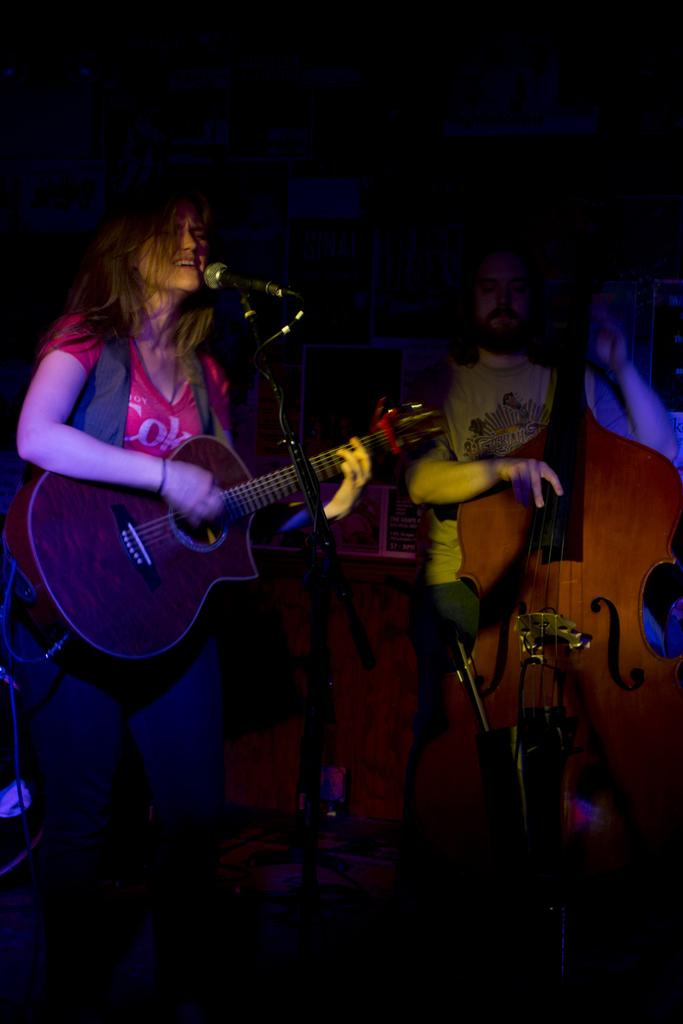What is the main subject of the image? The main subject of the image is a woman. What is the woman doing in the image? The woman is standing, singing, and holding a guitar. What object is the woman using to amplify her voice? There is a microphone ine in the image that the woman might be using. What other object is present in the image that the woman might be using? There is a stand in the image that could be used to support the guitar or other equipment. Can you describe the person in the background of the image? There is a guy in the background of the image, and he is holding a large guitar. How many dolls are sitting on the woman's lap while she plays the guitar? There are no dolls present in the image; the woman is holding a guitar and singing. What type of rabbit can be seen hopping around the microphone in the image? There is no rabbit present in the image; the microphone is likely being used by the woman for singing. 